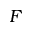Convert formula to latex. <formula><loc_0><loc_0><loc_500><loc_500>F</formula> 